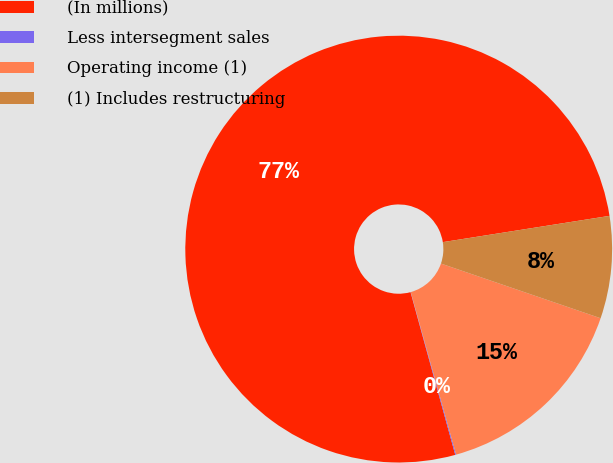Convert chart to OTSL. <chart><loc_0><loc_0><loc_500><loc_500><pie_chart><fcel>(In millions)<fcel>Less intersegment sales<fcel>Operating income (1)<fcel>(1) Includes restructuring<nl><fcel>76.78%<fcel>0.07%<fcel>15.41%<fcel>7.74%<nl></chart> 